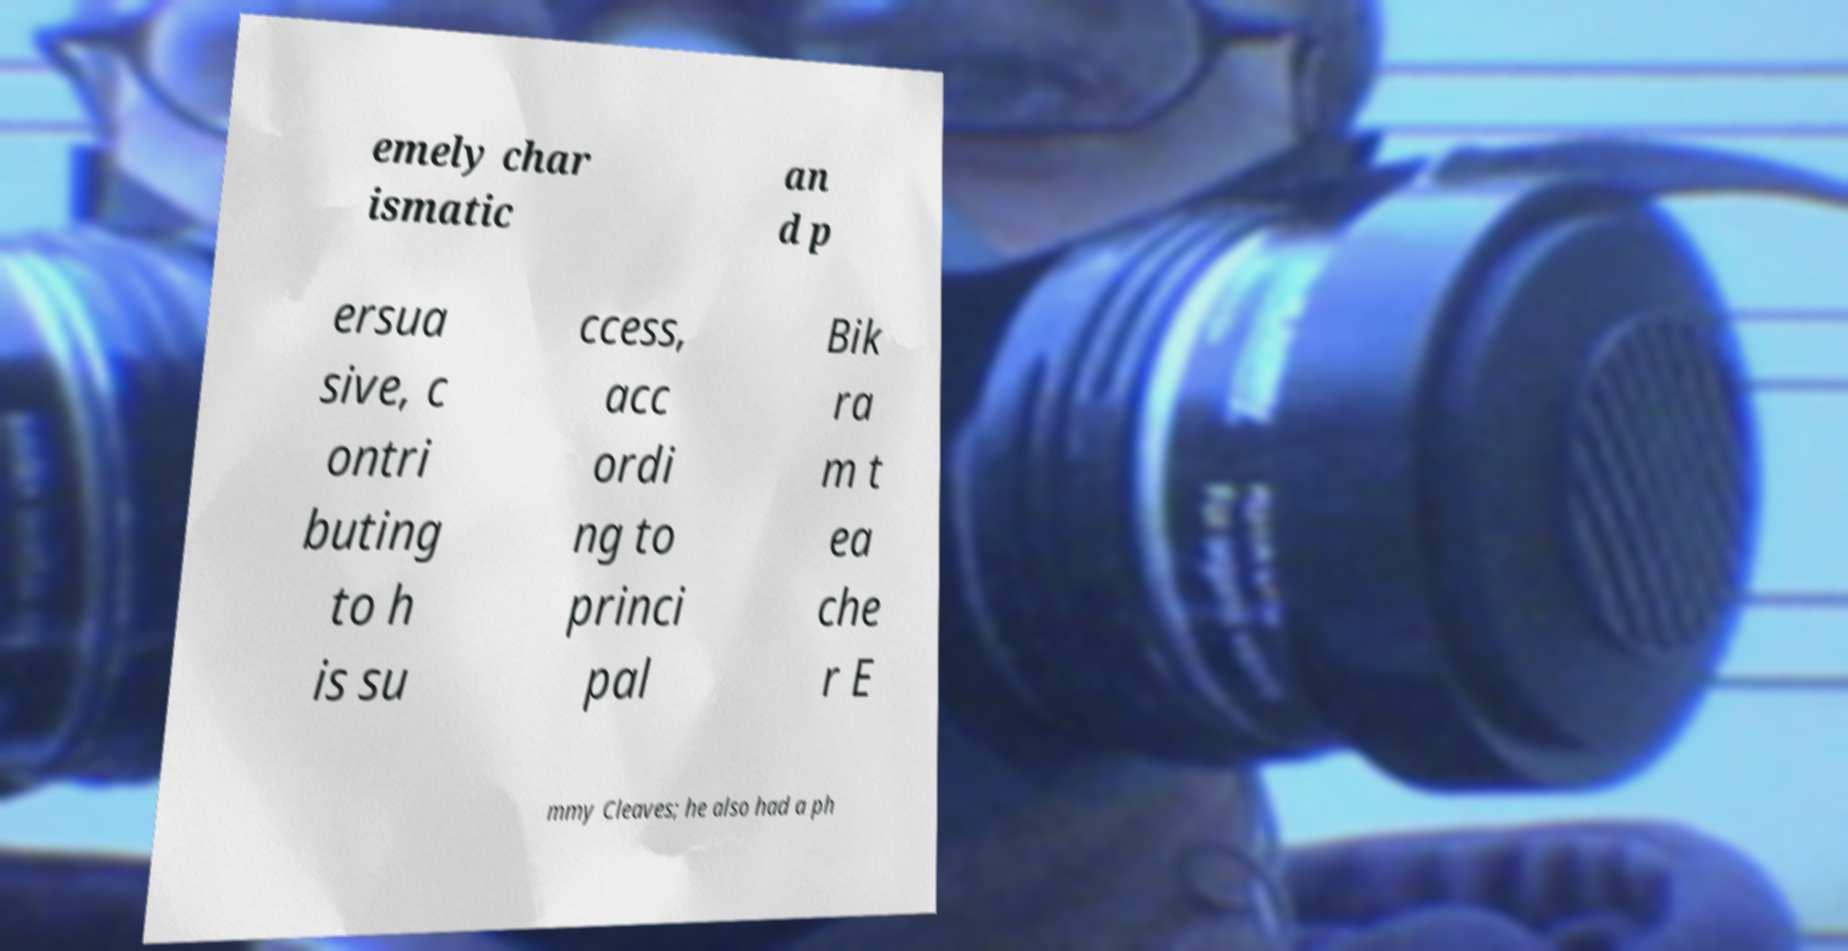Could you extract and type out the text from this image? emely char ismatic an d p ersua sive, c ontri buting to h is su ccess, acc ordi ng to princi pal Bik ra m t ea che r E mmy Cleaves; he also had a ph 